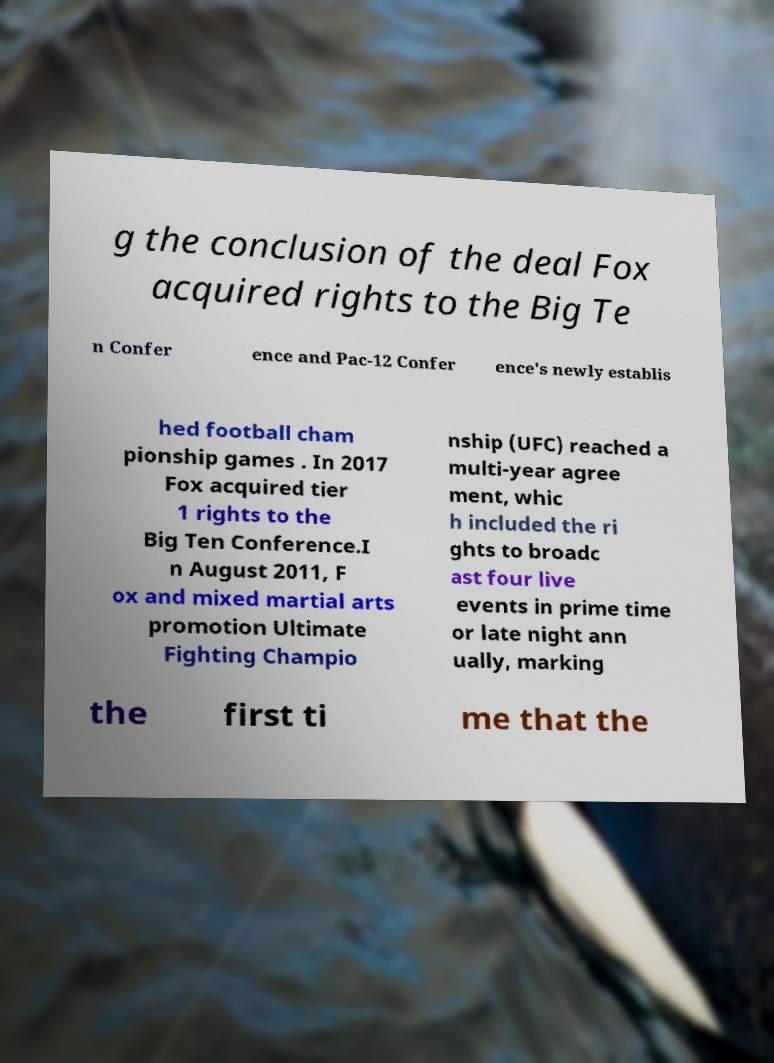Please identify and transcribe the text found in this image. g the conclusion of the deal Fox acquired rights to the Big Te n Confer ence and Pac-12 Confer ence's newly establis hed football cham pionship games . In 2017 Fox acquired tier 1 rights to the Big Ten Conference.I n August 2011, F ox and mixed martial arts promotion Ultimate Fighting Champio nship (UFC) reached a multi-year agree ment, whic h included the ri ghts to broadc ast four live events in prime time or late night ann ually, marking the first ti me that the 